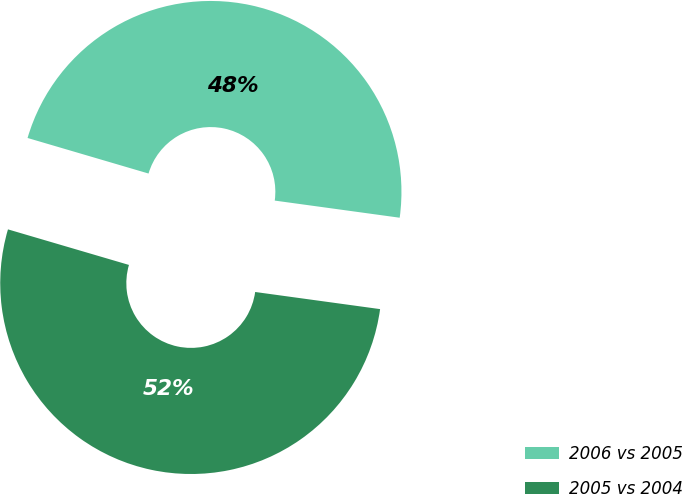<chart> <loc_0><loc_0><loc_500><loc_500><pie_chart><fcel>2006 vs 2005<fcel>2005 vs 2004<nl><fcel>47.62%<fcel>52.38%<nl></chart> 